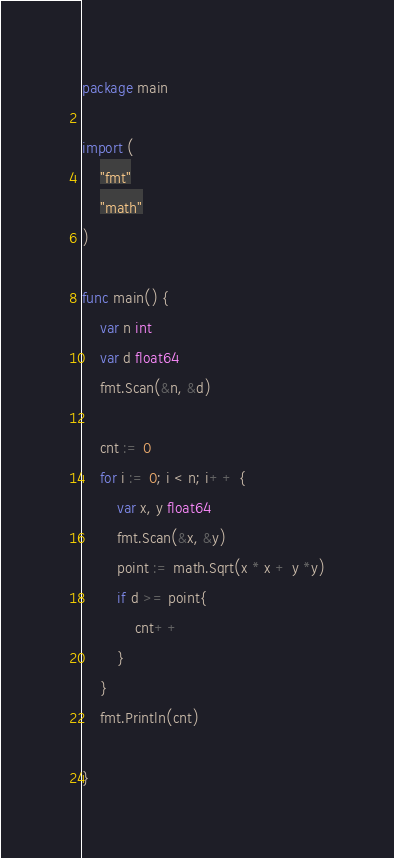Convert code to text. <code><loc_0><loc_0><loc_500><loc_500><_Go_>package main

import (
	"fmt"
	"math"
)

func main() {
	var n int
	var d float64
	fmt.Scan(&n, &d)

	cnt := 0
	for i := 0; i < n; i++ {
		var x, y float64
		fmt.Scan(&x, &y)
		point := math.Sqrt(x * x + y *y)
		if d >= point{
			cnt++
		}
	}
	fmt.Println(cnt)

}
</code> 